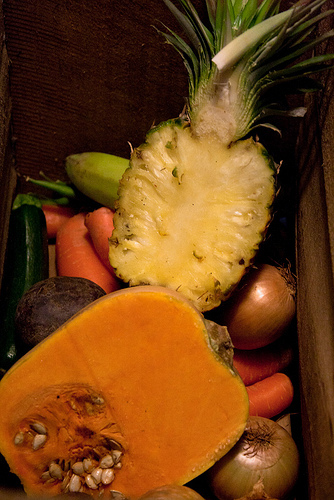<image>
Is the onion to the left of the carrot? No. The onion is not to the left of the carrot. From this viewpoint, they have a different horizontal relationship. Where is the melon in relation to the cucumber? Is it above the cucumber? Yes. The melon is positioned above the cucumber in the vertical space, higher up in the scene. Is the pineapple above the onion? Yes. The pineapple is positioned above the onion in the vertical space, higher up in the scene. 